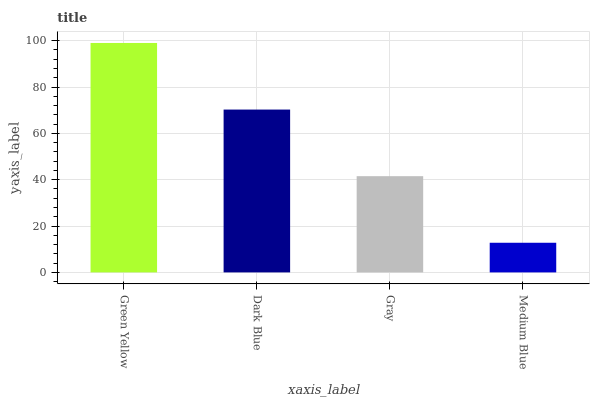Is Medium Blue the minimum?
Answer yes or no. Yes. Is Green Yellow the maximum?
Answer yes or no. Yes. Is Dark Blue the minimum?
Answer yes or no. No. Is Dark Blue the maximum?
Answer yes or no. No. Is Green Yellow greater than Dark Blue?
Answer yes or no. Yes. Is Dark Blue less than Green Yellow?
Answer yes or no. Yes. Is Dark Blue greater than Green Yellow?
Answer yes or no. No. Is Green Yellow less than Dark Blue?
Answer yes or no. No. Is Dark Blue the high median?
Answer yes or no. Yes. Is Gray the low median?
Answer yes or no. Yes. Is Medium Blue the high median?
Answer yes or no. No. Is Green Yellow the low median?
Answer yes or no. No. 